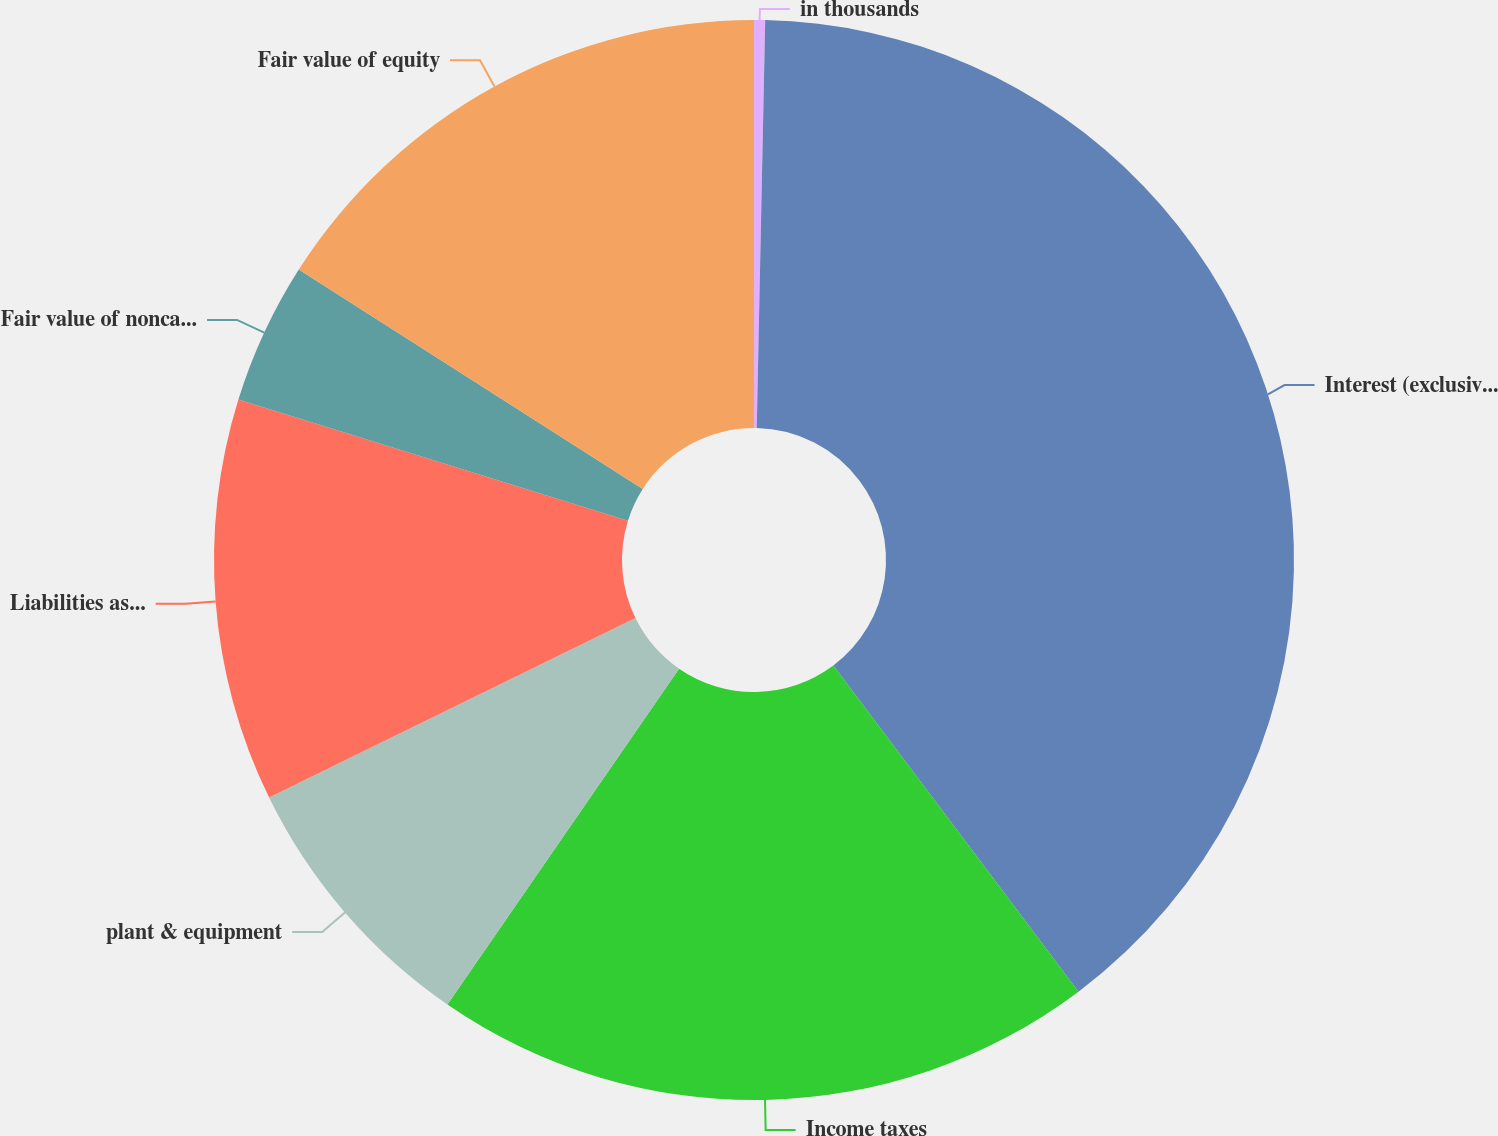Convert chart to OTSL. <chart><loc_0><loc_0><loc_500><loc_500><pie_chart><fcel>in thousands<fcel>Interest (exclusive of amount<fcel>Income taxes<fcel>plant & equipment<fcel>Liabilities assumed<fcel>Fair value of noncash assets<fcel>Fair value of equity<nl><fcel>0.33%<fcel>39.41%<fcel>19.87%<fcel>8.14%<fcel>12.05%<fcel>4.24%<fcel>15.96%<nl></chart> 